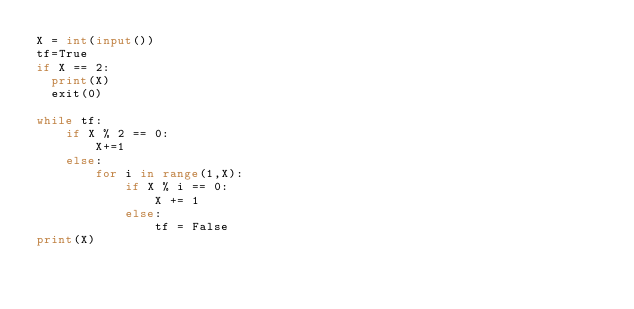Convert code to text. <code><loc_0><loc_0><loc_500><loc_500><_Python_>X = int(input())
tf=True
if X == 2:
  print(X)
  exit(0)
  
while tf:
    if X % 2 == 0:
        X+=1
    else:
        for i in range(1,X):
            if X % i == 0:
                X += 1
            else:
                tf = False
print(X)</code> 